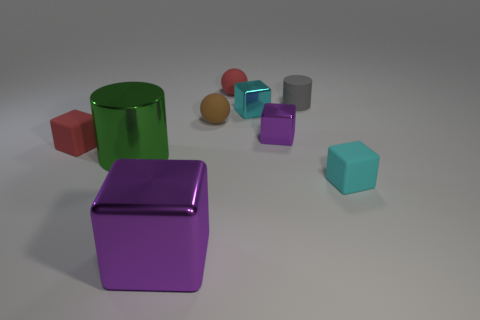There is a sphere in front of the gray cylinder; does it have the same size as the big purple metallic block?
Keep it short and to the point. No. Is the number of cyan cubes less than the number of small objects?
Provide a short and direct response. Yes. There is a big purple thing that is the same shape as the small purple shiny object; what is its material?
Your answer should be compact. Metal. Are there more purple things than big yellow matte cylinders?
Your answer should be very brief. Yes. What number of other objects are the same color as the tiny matte cylinder?
Give a very brief answer. 0. Does the tiny gray cylinder have the same material as the small sphere that is in front of the cyan metal block?
Your response must be concise. Yes. How many purple blocks are behind the purple object on the left side of the purple metallic cube behind the green cylinder?
Give a very brief answer. 1. Is the number of big purple blocks left of the shiny cylinder less than the number of small cubes that are right of the small purple thing?
Offer a very short reply. Yes. How many other things are there of the same material as the tiny purple block?
Keep it short and to the point. 3. What is the material of the red ball that is the same size as the gray matte cylinder?
Provide a succinct answer. Rubber. 